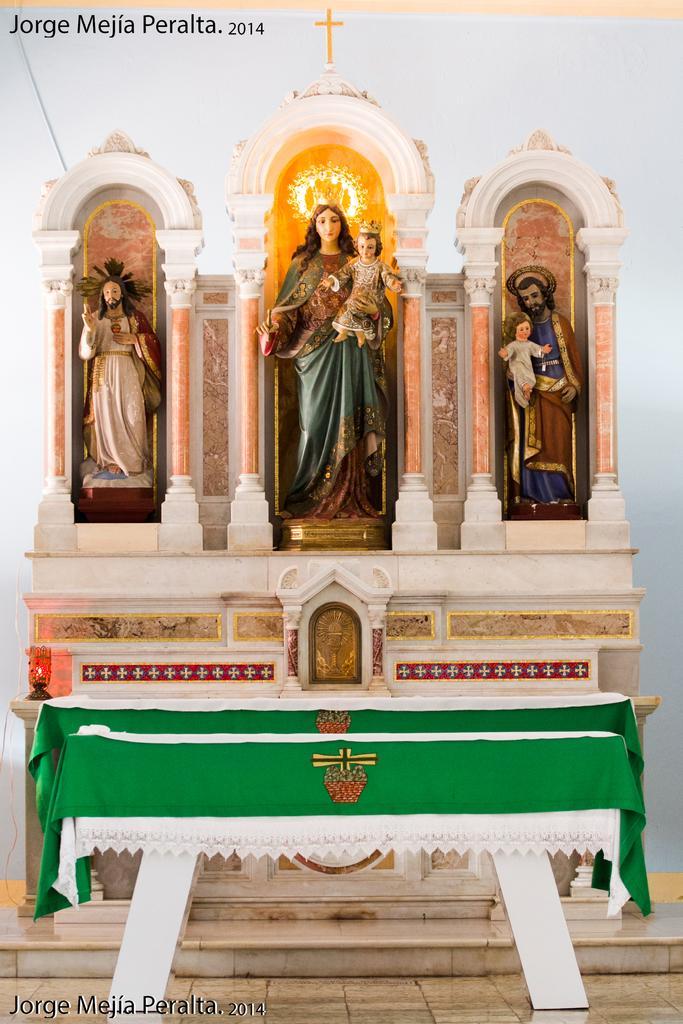Please provide a concise description of this image. In this image there are few human statues on the shelf. Left side there is lamp. There is a table covered with a cloth. Background there is wall. A human statue is holding a kid in his hands. 